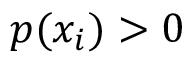Convert formula to latex. <formula><loc_0><loc_0><loc_500><loc_500>p ( x _ { i } ) > 0</formula> 